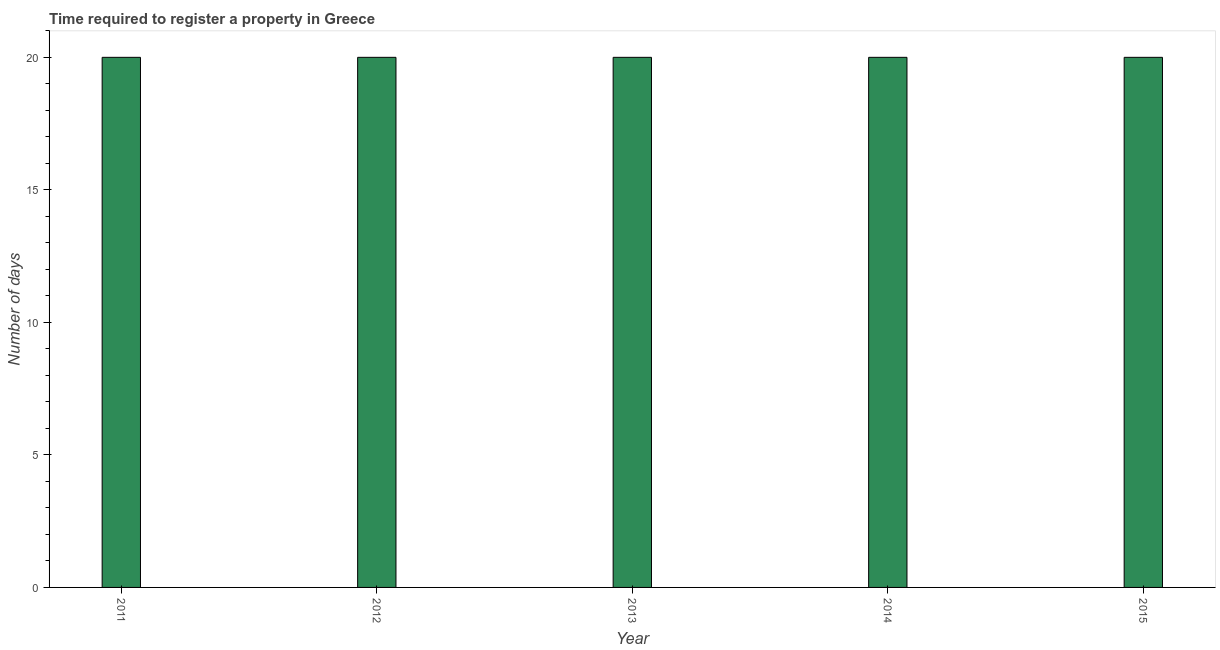Does the graph contain any zero values?
Provide a short and direct response. No. Does the graph contain grids?
Your answer should be very brief. No. What is the title of the graph?
Offer a terse response. Time required to register a property in Greece. What is the label or title of the X-axis?
Your answer should be very brief. Year. What is the label or title of the Y-axis?
Your response must be concise. Number of days. What is the number of days required to register property in 2014?
Provide a succinct answer. 20. Across all years, what is the minimum number of days required to register property?
Offer a very short reply. 20. In which year was the number of days required to register property minimum?
Your answer should be very brief. 2011. What is the difference between the number of days required to register property in 2012 and 2014?
Provide a short and direct response. 0. What is the average number of days required to register property per year?
Give a very brief answer. 20. What is the ratio of the number of days required to register property in 2014 to that in 2015?
Your answer should be compact. 1. Is the difference between the number of days required to register property in 2013 and 2014 greater than the difference between any two years?
Give a very brief answer. Yes. Is the sum of the number of days required to register property in 2012 and 2015 greater than the maximum number of days required to register property across all years?
Offer a very short reply. Yes. How many bars are there?
Provide a short and direct response. 5. What is the Number of days in 2011?
Your answer should be very brief. 20. What is the Number of days in 2013?
Provide a short and direct response. 20. What is the difference between the Number of days in 2011 and 2012?
Offer a very short reply. 0. What is the difference between the Number of days in 2011 and 2015?
Your response must be concise. 0. What is the difference between the Number of days in 2012 and 2015?
Keep it short and to the point. 0. What is the difference between the Number of days in 2013 and 2014?
Give a very brief answer. 0. What is the difference between the Number of days in 2014 and 2015?
Make the answer very short. 0. What is the ratio of the Number of days in 2011 to that in 2013?
Your response must be concise. 1. What is the ratio of the Number of days in 2011 to that in 2014?
Your response must be concise. 1. What is the ratio of the Number of days in 2012 to that in 2013?
Your response must be concise. 1. What is the ratio of the Number of days in 2012 to that in 2015?
Your answer should be compact. 1. 